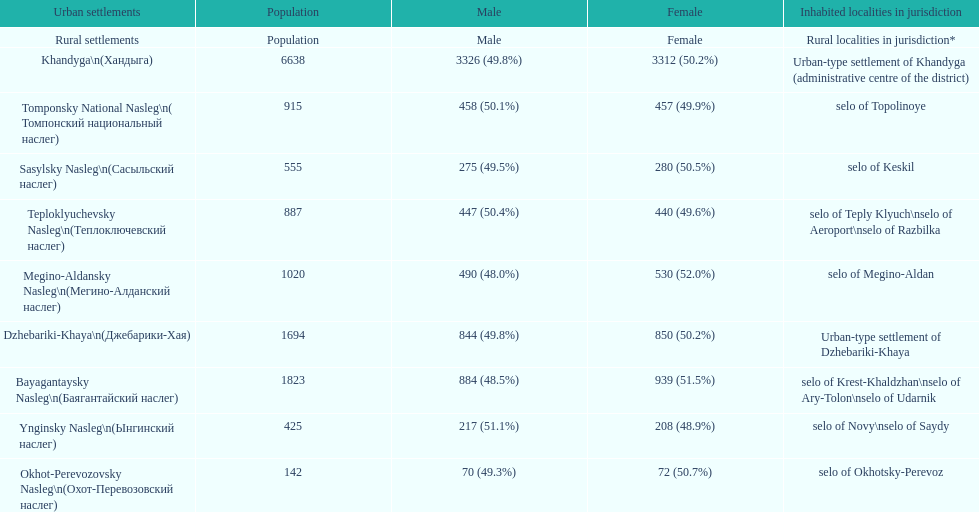What is the total population in dzhebariki-khaya? 1694. 